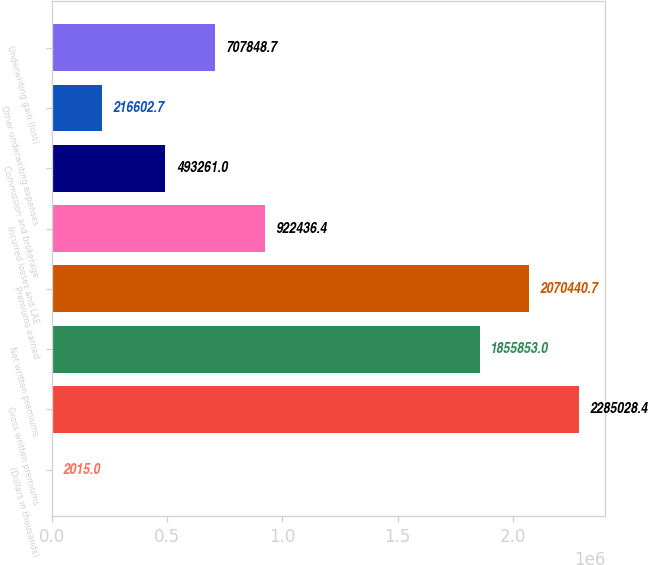<chart> <loc_0><loc_0><loc_500><loc_500><bar_chart><fcel>(Dollars in thousands)<fcel>Gross written premiums<fcel>Net written premiums<fcel>Premiums earned<fcel>Incurred losses and LAE<fcel>Commission and brokerage<fcel>Other underwriting expenses<fcel>Underwriting gain (loss)<nl><fcel>2015<fcel>2.28503e+06<fcel>1.85585e+06<fcel>2.07044e+06<fcel>922436<fcel>493261<fcel>216603<fcel>707849<nl></chart> 